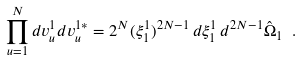<formula> <loc_0><loc_0><loc_500><loc_500>\prod _ { u = 1 } ^ { N } d v _ { u } ^ { 1 } d v _ { u } ^ { 1 * } = 2 ^ { N } ( \xi _ { 1 } ^ { 1 } ) ^ { 2 N - 1 } \, d \xi _ { 1 } ^ { 1 } \, d ^ { 2 N - 1 } \hat { \Omega } _ { 1 } \ .</formula> 